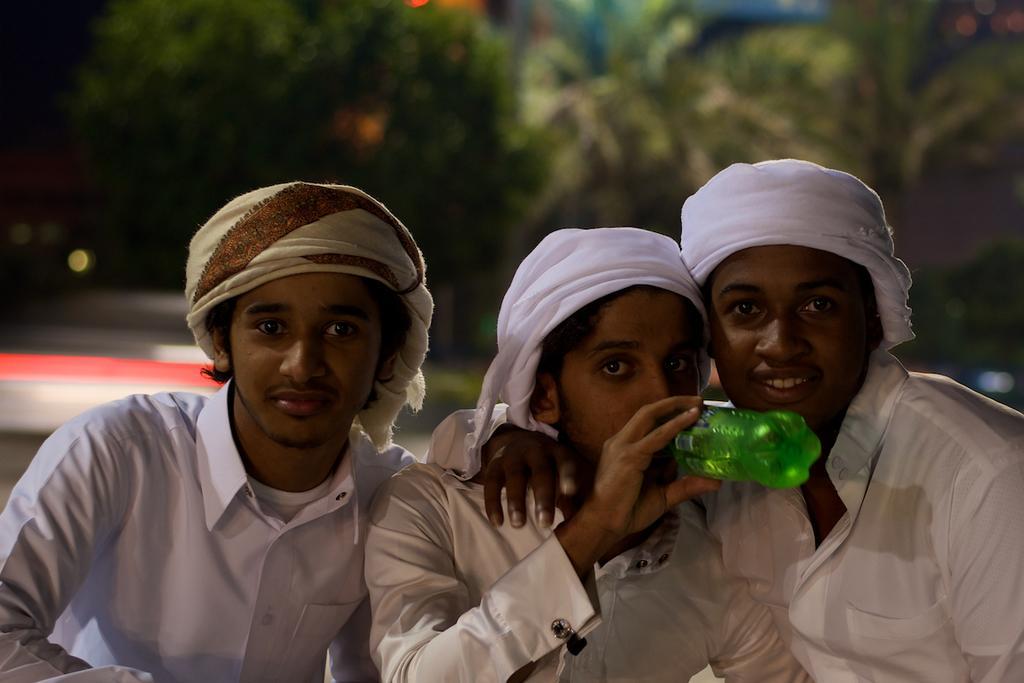In one or two sentences, can you explain what this image depicts? There are three people wearing white dress and sitting. These are the turbans on their heads. The person in the middle is holding bottle and drinking. At background I can see trees which are green in color. 